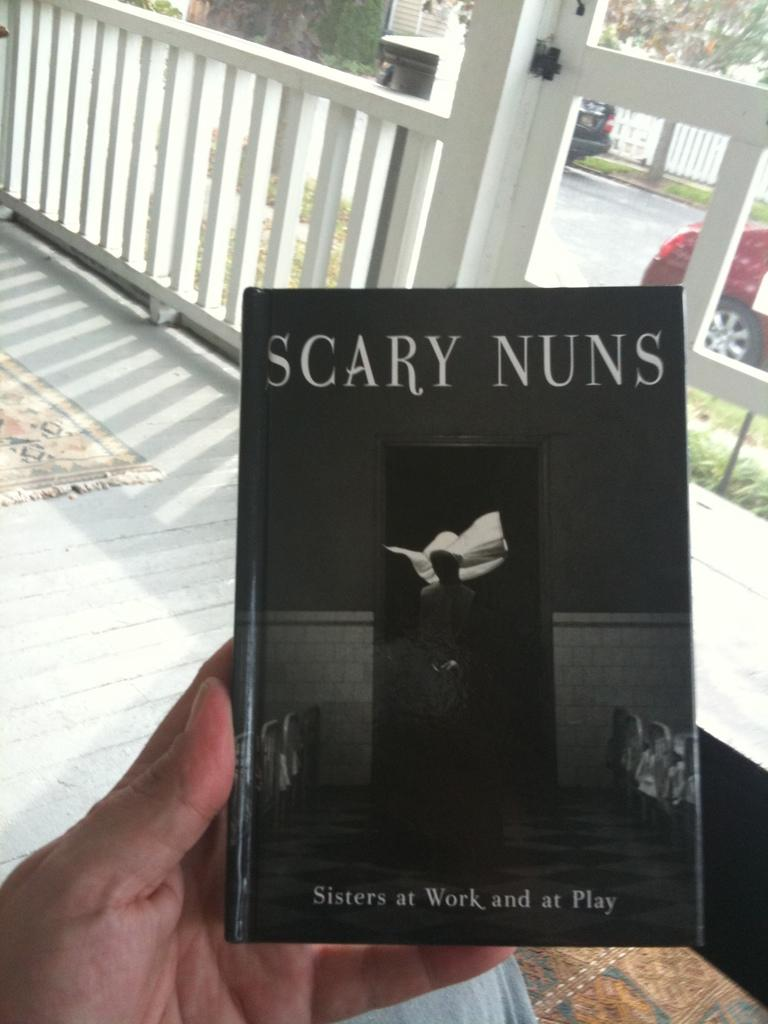<image>
Relay a brief, clear account of the picture shown. A hand is holding a booked titled Scary Nuns. 